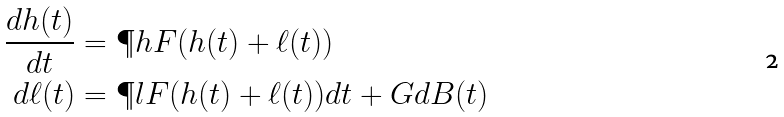Convert formula to latex. <formula><loc_0><loc_0><loc_500><loc_500>\frac { d h ( t ) } { d t } & = \P h F ( h ( t ) + \ell ( t ) ) \\ d \ell ( t ) & = \P l F ( h ( t ) + \ell ( t ) ) d t + G d B ( t )</formula> 